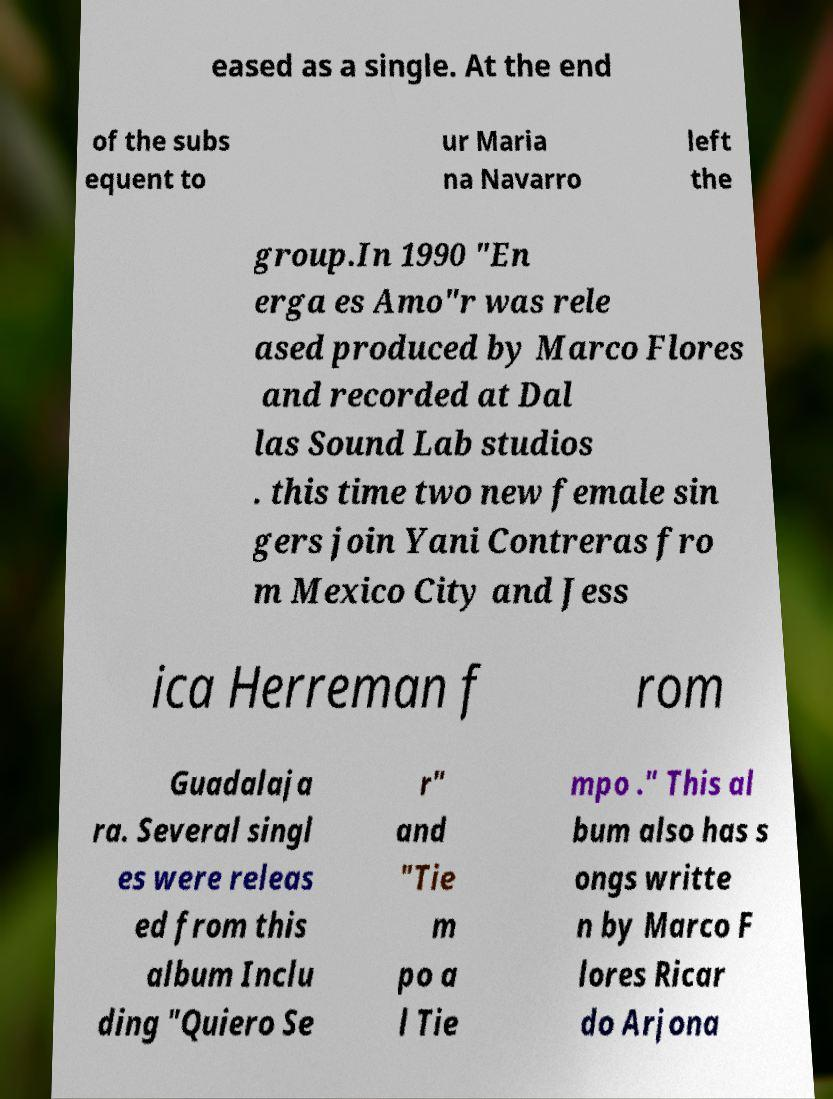Could you extract and type out the text from this image? eased as a single. At the end of the subs equent to ur Maria na Navarro left the group.In 1990 "En erga es Amo"r was rele ased produced by Marco Flores and recorded at Dal las Sound Lab studios . this time two new female sin gers join Yani Contreras fro m Mexico City and Jess ica Herreman f rom Guadalaja ra. Several singl es were releas ed from this album Inclu ding "Quiero Se r" and "Tie m po a l Tie mpo ." This al bum also has s ongs writte n by Marco F lores Ricar do Arjona 